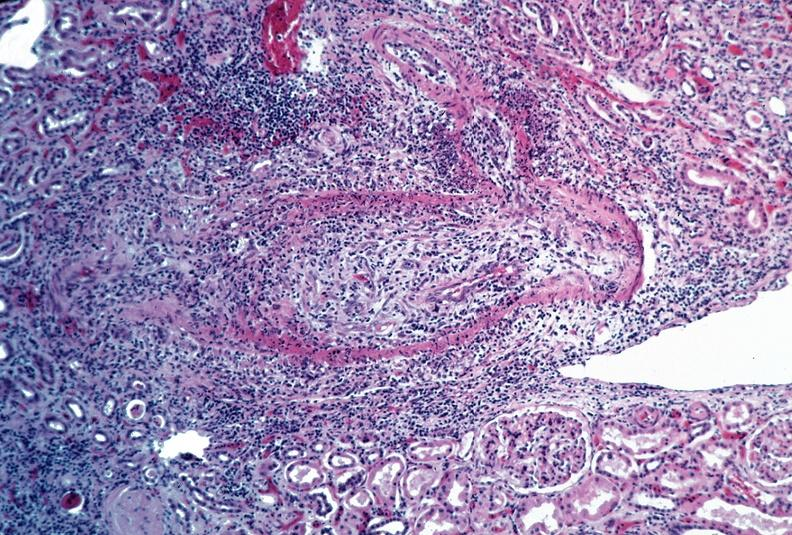does this image show vasculitis, polyarteritis nodosa?
Answer the question using a single word or phrase. Yes 